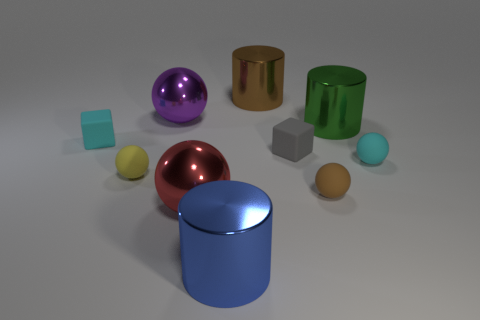Does the lighting in this image suggest a particular time of day? The image does not appear to represent a natural setting, and the lighting seems artificial, as if rendered for a 3D model demonstration. Therefore, it does not suggest a particular time of day but instead implies a controlled environment likely designed to showcase the objects without external influences. 